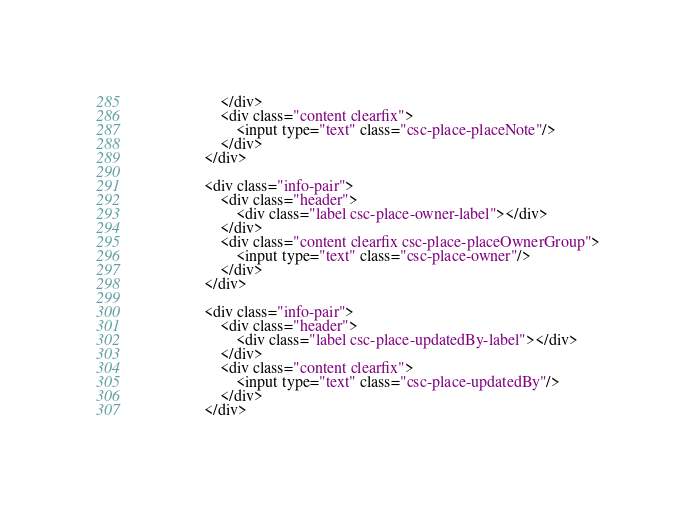<code> <loc_0><loc_0><loc_500><loc_500><_HTML_>                    </div>
                    <div class="content clearfix">
                        <input type="text" class="csc-place-placeNote"/>
                    </div>        
                </div>

                <div class="info-pair">
                    <div class="header">
                        <div class="label csc-place-owner-label"></div>
                    </div>
                    <div class="content clearfix csc-place-placeOwnerGroup">
                        <input type="text" class="csc-place-owner"/>
                    </div>        
                </div>

                <div class="info-pair">
                    <div class="header">
                        <div class="label csc-place-updatedBy-label"></div>
                    </div>
                    <div class="content clearfix">
                        <input type="text" class="csc-place-updatedBy"/>
                    </div>
                </div>
</code> 